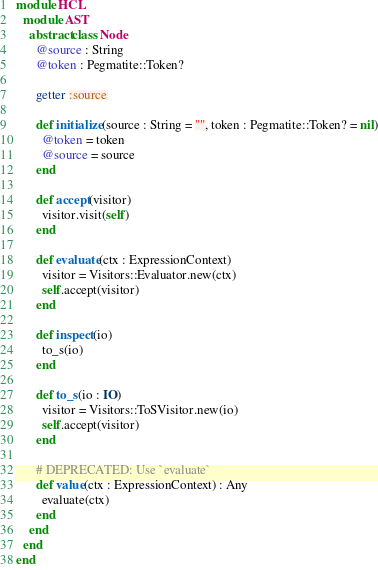<code> <loc_0><loc_0><loc_500><loc_500><_Crystal_>module HCL
  module AST
    abstract class Node
      @source : String
      @token : Pegmatite::Token?

      getter :source

      def initialize(source : String = "", token : Pegmatite::Token? = nil)
        @token = token
        @source = source
      end

      def accept(visitor)
        visitor.visit(self)
      end

      def evaluate(ctx : ExpressionContext)
        visitor = Visitors::Evaluator.new(ctx)
        self.accept(visitor)
      end

      def inspect(io)
        to_s(io)
      end

      def to_s(io : IO)
        visitor = Visitors::ToSVisitor.new(io)
        self.accept(visitor)
      end

      # DEPRECATED: Use `evaluate`
      def value(ctx : ExpressionContext) : Any
        evaluate(ctx)
      end
    end
  end
end
</code> 